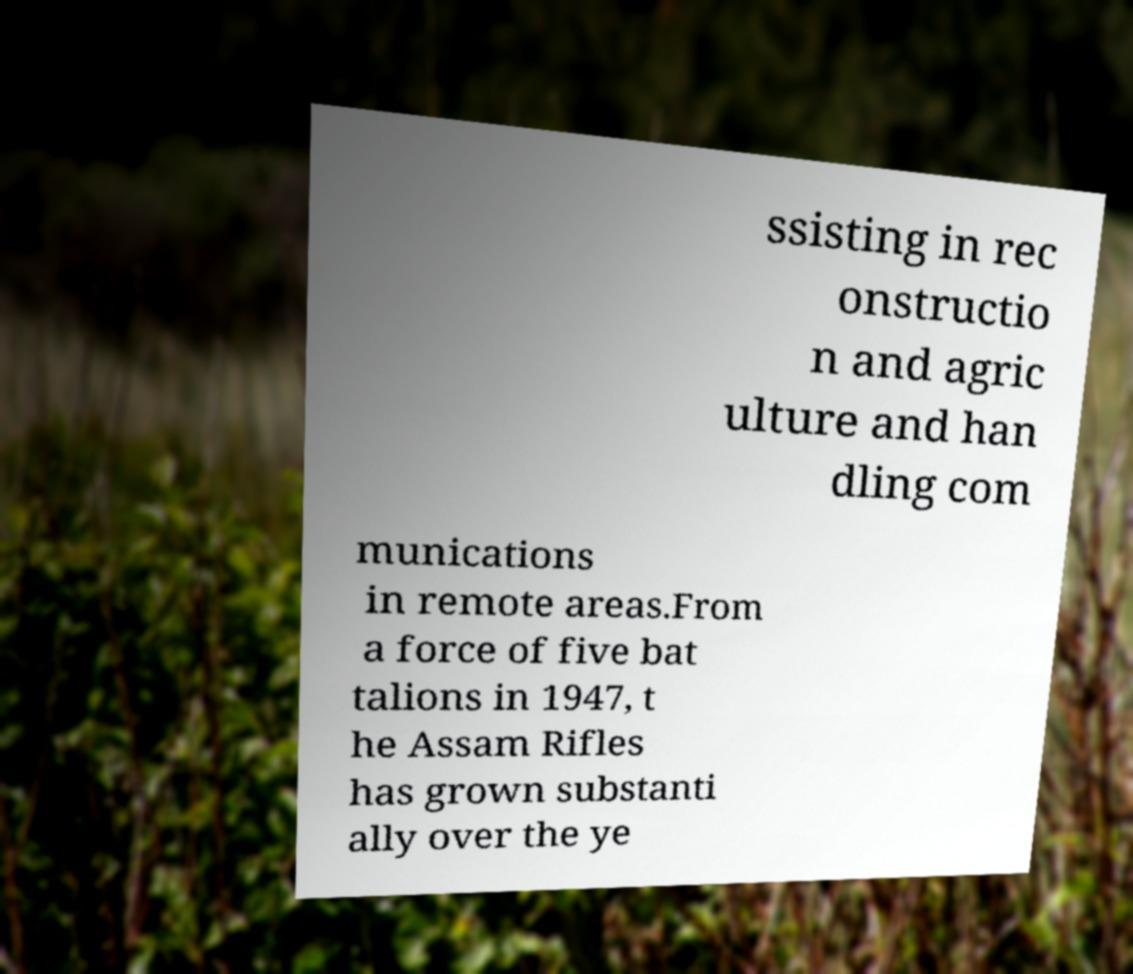Can you accurately transcribe the text from the provided image for me? ssisting in rec onstructio n and agric ulture and han dling com munications in remote areas.From a force of five bat talions in 1947, t he Assam Rifles has grown substanti ally over the ye 